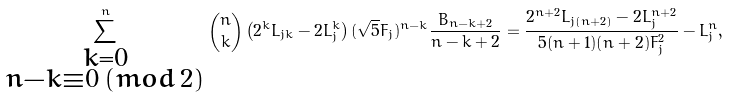Convert formula to latex. <formula><loc_0><loc_0><loc_500><loc_500>\sum _ { \substack { k = 0 \\ n - k \equiv 0 \, ( m o d \, 2 ) } } ^ { n } \binom { n } { k } \left ( 2 ^ { k } L _ { j k } - 2 L _ { j } ^ { k } \right ) ( \sqrt { 5 } F _ { j } ) ^ { n - k } \frac { B _ { n - k + 2 } } { n - k + 2 } = \frac { 2 ^ { n + 2 } L _ { j ( n + 2 ) } - 2 L _ { j } ^ { n + 2 } } { 5 ( n + 1 ) ( n + 2 ) F _ { j } ^ { 2 } } - L _ { j } ^ { n } ,</formula> 